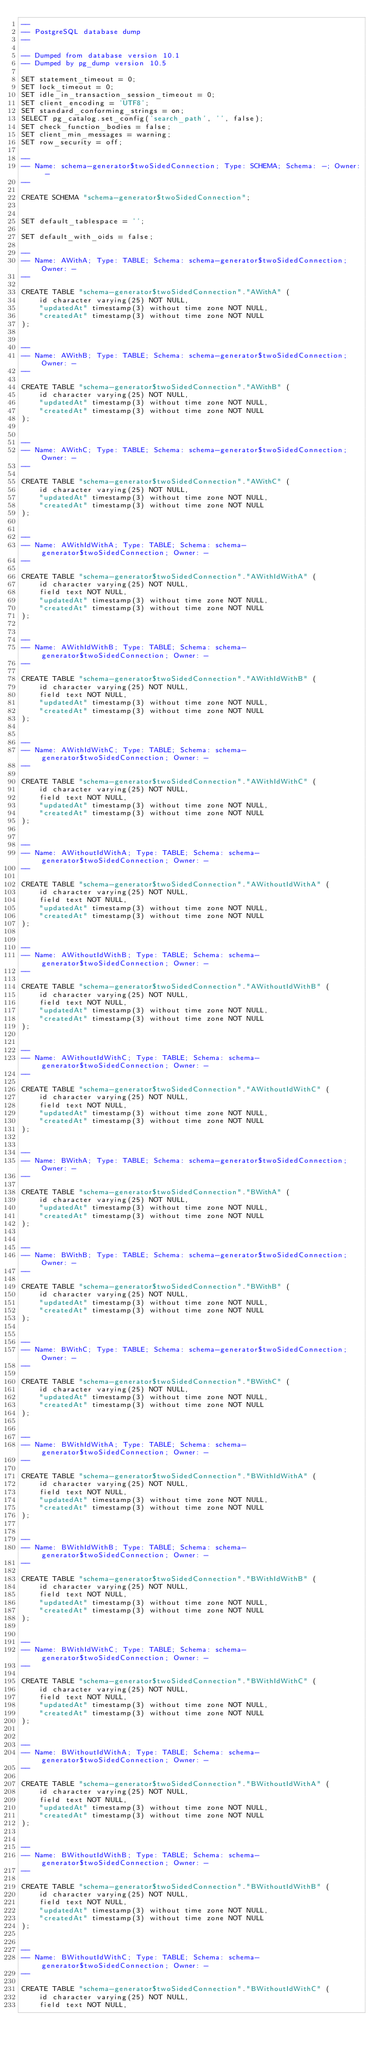Convert code to text. <code><loc_0><loc_0><loc_500><loc_500><_SQL_>--
-- PostgreSQL database dump
--

-- Dumped from database version 10.1
-- Dumped by pg_dump version 10.5

SET statement_timeout = 0;
SET lock_timeout = 0;
SET idle_in_transaction_session_timeout = 0;
SET client_encoding = 'UTF8';
SET standard_conforming_strings = on;
SELECT pg_catalog.set_config('search_path', '', false);
SET check_function_bodies = false;
SET client_min_messages = warning;
SET row_security = off;

--
-- Name: schema-generator$twoSidedConnection; Type: SCHEMA; Schema: -; Owner: -
--

CREATE SCHEMA "schema-generator$twoSidedConnection";


SET default_tablespace = '';

SET default_with_oids = false;

--
-- Name: AWithA; Type: TABLE; Schema: schema-generator$twoSidedConnection; Owner: -
--

CREATE TABLE "schema-generator$twoSidedConnection"."AWithA" (
    id character varying(25) NOT NULL,
    "updatedAt" timestamp(3) without time zone NOT NULL,
    "createdAt" timestamp(3) without time zone NOT NULL
);


--
-- Name: AWithB; Type: TABLE; Schema: schema-generator$twoSidedConnection; Owner: -
--

CREATE TABLE "schema-generator$twoSidedConnection"."AWithB" (
    id character varying(25) NOT NULL,
    "updatedAt" timestamp(3) without time zone NOT NULL,
    "createdAt" timestamp(3) without time zone NOT NULL
);


--
-- Name: AWithC; Type: TABLE; Schema: schema-generator$twoSidedConnection; Owner: -
--

CREATE TABLE "schema-generator$twoSidedConnection"."AWithC" (
    id character varying(25) NOT NULL,
    "updatedAt" timestamp(3) without time zone NOT NULL,
    "createdAt" timestamp(3) without time zone NOT NULL
);


--
-- Name: AWithIdWithA; Type: TABLE; Schema: schema-generator$twoSidedConnection; Owner: -
--

CREATE TABLE "schema-generator$twoSidedConnection"."AWithIdWithA" (
    id character varying(25) NOT NULL,
    field text NOT NULL,
    "updatedAt" timestamp(3) without time zone NOT NULL,
    "createdAt" timestamp(3) without time zone NOT NULL
);


--
-- Name: AWithIdWithB; Type: TABLE; Schema: schema-generator$twoSidedConnection; Owner: -
--

CREATE TABLE "schema-generator$twoSidedConnection"."AWithIdWithB" (
    id character varying(25) NOT NULL,
    field text NOT NULL,
    "updatedAt" timestamp(3) without time zone NOT NULL,
    "createdAt" timestamp(3) without time zone NOT NULL
);


--
-- Name: AWithIdWithC; Type: TABLE; Schema: schema-generator$twoSidedConnection; Owner: -
--

CREATE TABLE "schema-generator$twoSidedConnection"."AWithIdWithC" (
    id character varying(25) NOT NULL,
    field text NOT NULL,
    "updatedAt" timestamp(3) without time zone NOT NULL,
    "createdAt" timestamp(3) without time zone NOT NULL
);


--
-- Name: AWithoutIdWithA; Type: TABLE; Schema: schema-generator$twoSidedConnection; Owner: -
--

CREATE TABLE "schema-generator$twoSidedConnection"."AWithoutIdWithA" (
    id character varying(25) NOT NULL,
    field text NOT NULL,
    "updatedAt" timestamp(3) without time zone NOT NULL,
    "createdAt" timestamp(3) without time zone NOT NULL
);


--
-- Name: AWithoutIdWithB; Type: TABLE; Schema: schema-generator$twoSidedConnection; Owner: -
--

CREATE TABLE "schema-generator$twoSidedConnection"."AWithoutIdWithB" (
    id character varying(25) NOT NULL,
    field text NOT NULL,
    "updatedAt" timestamp(3) without time zone NOT NULL,
    "createdAt" timestamp(3) without time zone NOT NULL
);


--
-- Name: AWithoutIdWithC; Type: TABLE; Schema: schema-generator$twoSidedConnection; Owner: -
--

CREATE TABLE "schema-generator$twoSidedConnection"."AWithoutIdWithC" (
    id character varying(25) NOT NULL,
    field text NOT NULL,
    "updatedAt" timestamp(3) without time zone NOT NULL,
    "createdAt" timestamp(3) without time zone NOT NULL
);


--
-- Name: BWithA; Type: TABLE; Schema: schema-generator$twoSidedConnection; Owner: -
--

CREATE TABLE "schema-generator$twoSidedConnection"."BWithA" (
    id character varying(25) NOT NULL,
    "updatedAt" timestamp(3) without time zone NOT NULL,
    "createdAt" timestamp(3) without time zone NOT NULL
);


--
-- Name: BWithB; Type: TABLE; Schema: schema-generator$twoSidedConnection; Owner: -
--

CREATE TABLE "schema-generator$twoSidedConnection"."BWithB" (
    id character varying(25) NOT NULL,
    "updatedAt" timestamp(3) without time zone NOT NULL,
    "createdAt" timestamp(3) without time zone NOT NULL
);


--
-- Name: BWithC; Type: TABLE; Schema: schema-generator$twoSidedConnection; Owner: -
--

CREATE TABLE "schema-generator$twoSidedConnection"."BWithC" (
    id character varying(25) NOT NULL,
    "updatedAt" timestamp(3) without time zone NOT NULL,
    "createdAt" timestamp(3) without time zone NOT NULL
);


--
-- Name: BWithIdWithA; Type: TABLE; Schema: schema-generator$twoSidedConnection; Owner: -
--

CREATE TABLE "schema-generator$twoSidedConnection"."BWithIdWithA" (
    id character varying(25) NOT NULL,
    field text NOT NULL,
    "updatedAt" timestamp(3) without time zone NOT NULL,
    "createdAt" timestamp(3) without time zone NOT NULL
);


--
-- Name: BWithIdWithB; Type: TABLE; Schema: schema-generator$twoSidedConnection; Owner: -
--

CREATE TABLE "schema-generator$twoSidedConnection"."BWithIdWithB" (
    id character varying(25) NOT NULL,
    field text NOT NULL,
    "updatedAt" timestamp(3) without time zone NOT NULL,
    "createdAt" timestamp(3) without time zone NOT NULL
);


--
-- Name: BWithIdWithC; Type: TABLE; Schema: schema-generator$twoSidedConnection; Owner: -
--

CREATE TABLE "schema-generator$twoSidedConnection"."BWithIdWithC" (
    id character varying(25) NOT NULL,
    field text NOT NULL,
    "updatedAt" timestamp(3) without time zone NOT NULL,
    "createdAt" timestamp(3) without time zone NOT NULL
);


--
-- Name: BWithoutIdWithA; Type: TABLE; Schema: schema-generator$twoSidedConnection; Owner: -
--

CREATE TABLE "schema-generator$twoSidedConnection"."BWithoutIdWithA" (
    id character varying(25) NOT NULL,
    field text NOT NULL,
    "updatedAt" timestamp(3) without time zone NOT NULL,
    "createdAt" timestamp(3) without time zone NOT NULL
);


--
-- Name: BWithoutIdWithB; Type: TABLE; Schema: schema-generator$twoSidedConnection; Owner: -
--

CREATE TABLE "schema-generator$twoSidedConnection"."BWithoutIdWithB" (
    id character varying(25) NOT NULL,
    field text NOT NULL,
    "updatedAt" timestamp(3) without time zone NOT NULL,
    "createdAt" timestamp(3) without time zone NOT NULL
);


--
-- Name: BWithoutIdWithC; Type: TABLE; Schema: schema-generator$twoSidedConnection; Owner: -
--

CREATE TABLE "schema-generator$twoSidedConnection"."BWithoutIdWithC" (
    id character varying(25) NOT NULL,
    field text NOT NULL,</code> 